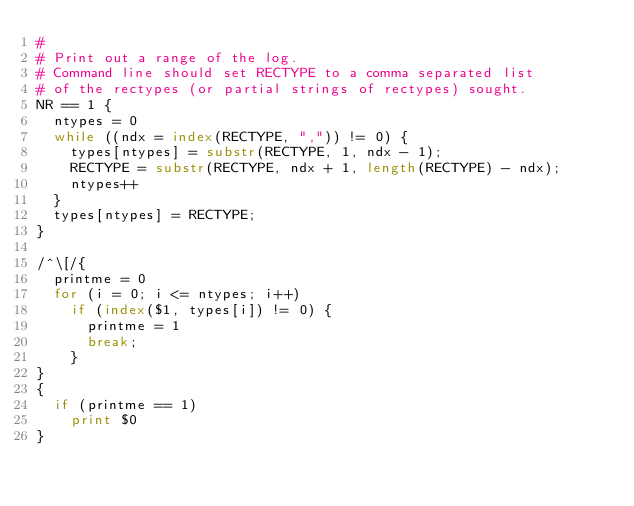<code> <loc_0><loc_0><loc_500><loc_500><_Awk_>#
# Print out a range of the log.
# Command line should set RECTYPE to a comma separated list
# of the rectypes (or partial strings of rectypes) sought.
NR == 1 {
	ntypes = 0
	while ((ndx = index(RECTYPE, ",")) != 0) {
		types[ntypes] = substr(RECTYPE, 1, ndx - 1);
		RECTYPE = substr(RECTYPE, ndx + 1, length(RECTYPE) - ndx);
		ntypes++
	}
	types[ntypes] = RECTYPE;
}

/^\[/{
	printme = 0
	for (i = 0; i <= ntypes; i++)
		if (index($1, types[i]) != 0) {
			printme = 1
			break;
		}
}
{
	if (printme == 1)
		print $0
}
</code> 